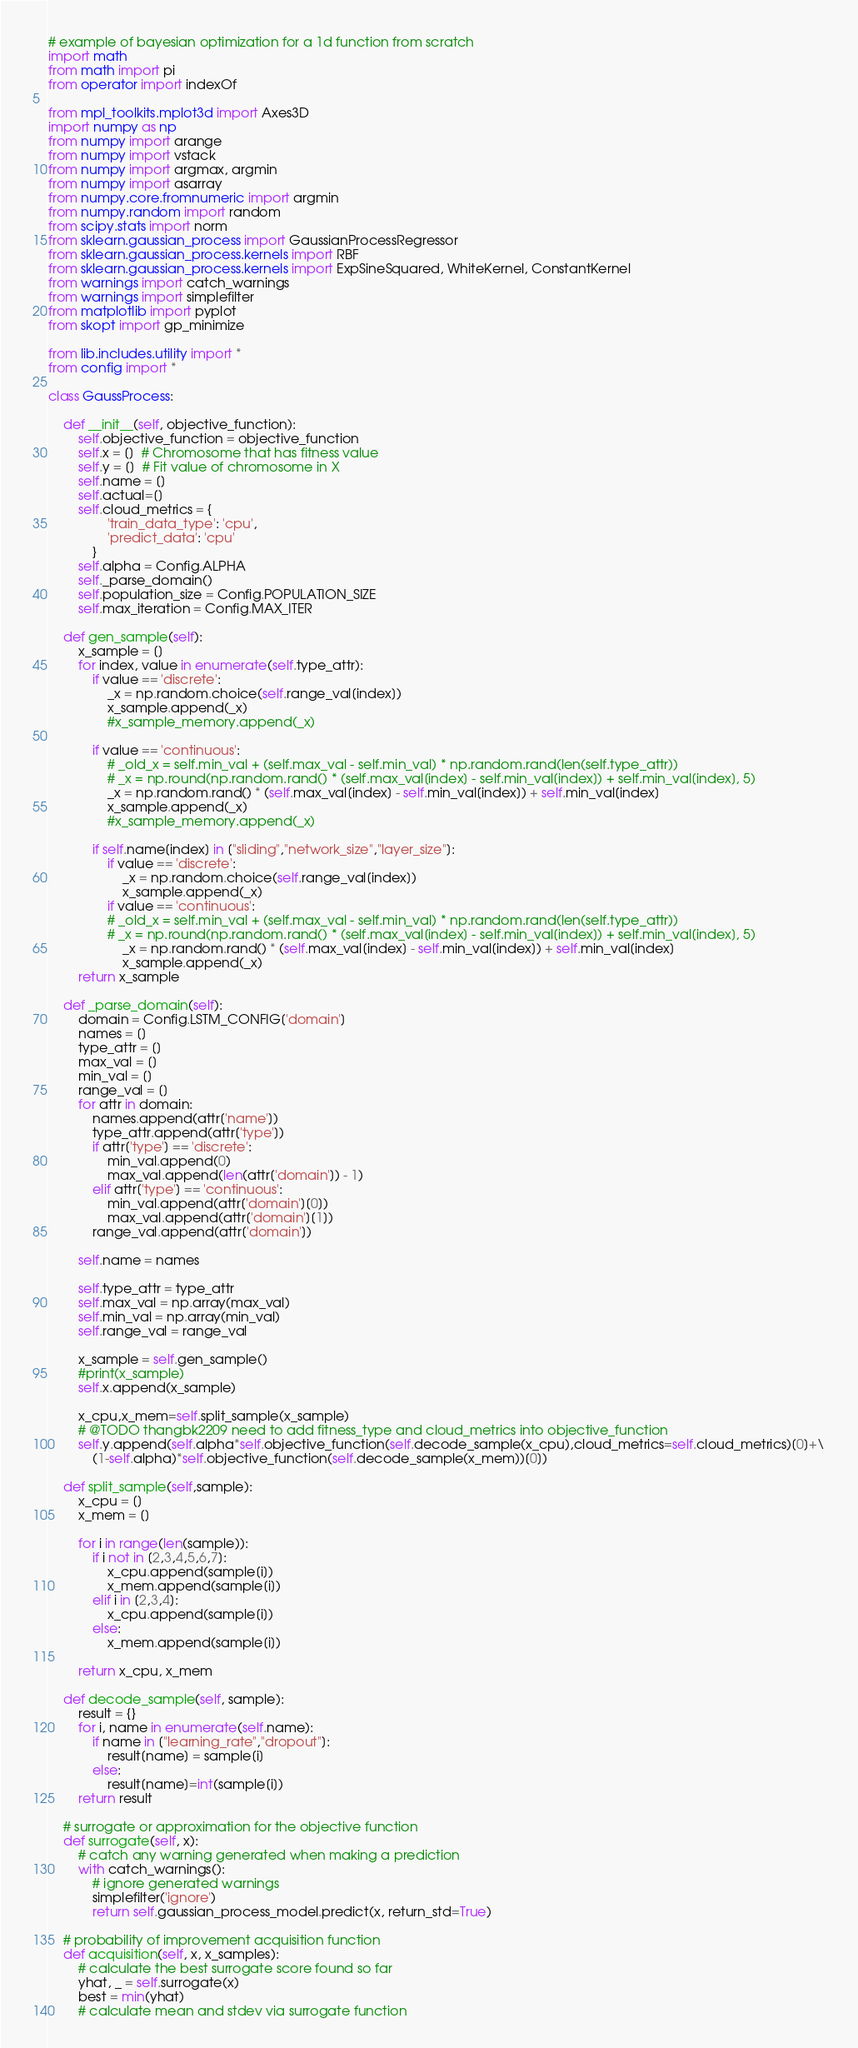Convert code to text. <code><loc_0><loc_0><loc_500><loc_500><_Python_># example of bayesian optimization for a 1d function from scratch
import math
from math import pi
from operator import indexOf

from mpl_toolkits.mplot3d import Axes3D
import numpy as np
from numpy import arange
from numpy import vstack
from numpy import argmax, argmin
from numpy import asarray
from numpy.core.fromnumeric import argmin
from numpy.random import random
from scipy.stats import norm
from sklearn.gaussian_process import GaussianProcessRegressor
from sklearn.gaussian_process.kernels import RBF
from sklearn.gaussian_process.kernels import ExpSineSquared, WhiteKernel, ConstantKernel
from warnings import catch_warnings
from warnings import simplefilter
from matplotlib import pyplot 
from skopt import gp_minimize

from lib.includes.utility import *
from config import *

class GaussProcess:

    def __init__(self, objective_function):
        self.objective_function = objective_function
        self.x = []  # Chromosome that has fitness value
        self.y = []  # Fit value of chromosome in X
        self.name = []
        self.actual=[]
        self.cloud_metrics = {
                'train_data_type': 'cpu',
                'predict_data': 'cpu'
            }
        self.alpha = Config.ALPHA
        self._parse_domain()
        self.population_size = Config.POPULATION_SIZE
        self.max_iteration = Config.MAX_ITER

    def gen_sample(self):
        x_sample = []
        for index, value in enumerate(self.type_attr):
            if value == 'discrete':
                _x = np.random.choice(self.range_val[index])
                x_sample.append(_x)
                #x_sample_memory.append(_x)

            if value == 'continuous':
                # _old_x = self.min_val + (self.max_val - self.min_val) * np.random.rand(len(self.type_attr))
                # _x = np.round(np.random.rand() * (self.max_val[index] - self.min_val[index]) + self.min_val[index], 5)
                _x = np.random.rand() * (self.max_val[index] - self.min_val[index]) + self.min_val[index]
                x_sample.append(_x)
                #x_sample_memory.append(_x)

            if self.name[index] in ["sliding","network_size","layer_size"]:
                if value == 'discrete':
                    _x = np.random.choice(self.range_val[index])
                    x_sample.append(_x)
                if value == 'continuous':
                # _old_x = self.min_val + (self.max_val - self.min_val) * np.random.rand(len(self.type_attr))
                # _x = np.round(np.random.rand() * (self.max_val[index] - self.min_val[index]) + self.min_val[index], 5)
                    _x = np.random.rand() * (self.max_val[index] - self.min_val[index]) + self.min_val[index]
                    x_sample.append(_x)
        return x_sample

    def _parse_domain(self):
        domain = Config.LSTM_CONFIG['domain']
        names = []
        type_attr = []
        max_val = []
        min_val = []
        range_val = []
        for attr in domain:
            names.append(attr['name'])
            type_attr.append(attr['type'])
            if attr['type'] == 'discrete':
                min_val.append(0)
                max_val.append(len(attr['domain']) - 1)
            elif attr['type'] == 'continuous':
                min_val.append(attr['domain'][0])
                max_val.append(attr['domain'][1])
            range_val.append(attr['domain'])

        self.name = names
        
        self.type_attr = type_attr
        self.max_val = np.array(max_val)
        self.min_val = np.array(min_val)
        self.range_val = range_val

        x_sample = self.gen_sample()
        #print(x_sample)
        self.x.append(x_sample)
        
        x_cpu,x_mem=self.split_sample(x_sample)
        # @TODO thangbk2209 need to add fitness_type and cloud_metrics into objective_function
        self.y.append(self.alpha*self.objective_function(self.decode_sample(x_cpu),cloud_metrics=self.cloud_metrics)[0]+\
            (1-self.alpha)*self.objective_function(self.decode_sample(x_mem))[0])

    def split_sample(self,sample):
        x_cpu = []
        x_mem = []

        for i in range(len(sample)):
            if i not in [2,3,4,5,6,7]:
                x_cpu.append(sample[i])
                x_mem.append(sample[i])
            elif i in [2,3,4]:
                x_cpu.append(sample[i])
            else:
                x_mem.append(sample[i])

        return x_cpu, x_mem

    def decode_sample(self, sample):
        result = {}
        for i, name in enumerate(self.name):
            if name in ["learning_rate","dropout"]:
                result[name] = sample[i]
            else:
                result[name]=int(sample[i])
        return result

    # surrogate or approximation for the objective function
    def surrogate(self, x):
        # catch any warning generated when making a prediction
        with catch_warnings():
            # ignore generated warnings
            simplefilter('ignore')
            return self.gaussian_process_model.predict(x, return_std=True)

    # probability of improvement acquisition function
    def acquisition(self, x, x_samples):
        # calculate the best surrogate score found so far
        yhat, _ = self.surrogate(x)
        best = min(yhat)
        # calculate mean and stdev via surrogate function</code> 